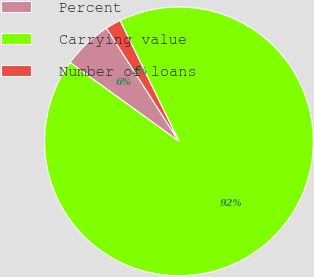<chart> <loc_0><loc_0><loc_500><loc_500><pie_chart><fcel>Percent<fcel>Carrying value<fcel>Number of loans<nl><fcel>5.97%<fcel>92.18%<fcel>1.84%<nl></chart> 